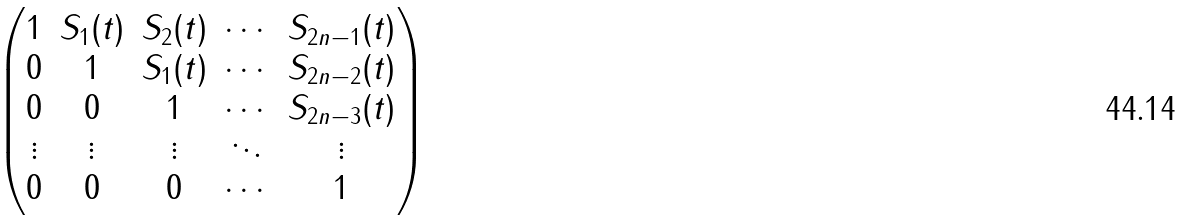<formula> <loc_0><loc_0><loc_500><loc_500>\begin{pmatrix} 1 & S _ { 1 } ( t ) & S _ { 2 } ( t ) & \cdots & S _ { 2 n - 1 } ( t ) \\ 0 & 1 & S _ { 1 } ( t ) & \cdots & S _ { 2 n - 2 } ( t ) \\ 0 & 0 & 1 & \cdots & S _ { 2 n - 3 } ( t ) \\ \vdots & \vdots & \vdots & \ddots & \vdots \\ 0 & 0 & 0 & \cdots & 1 \end{pmatrix}</formula> 